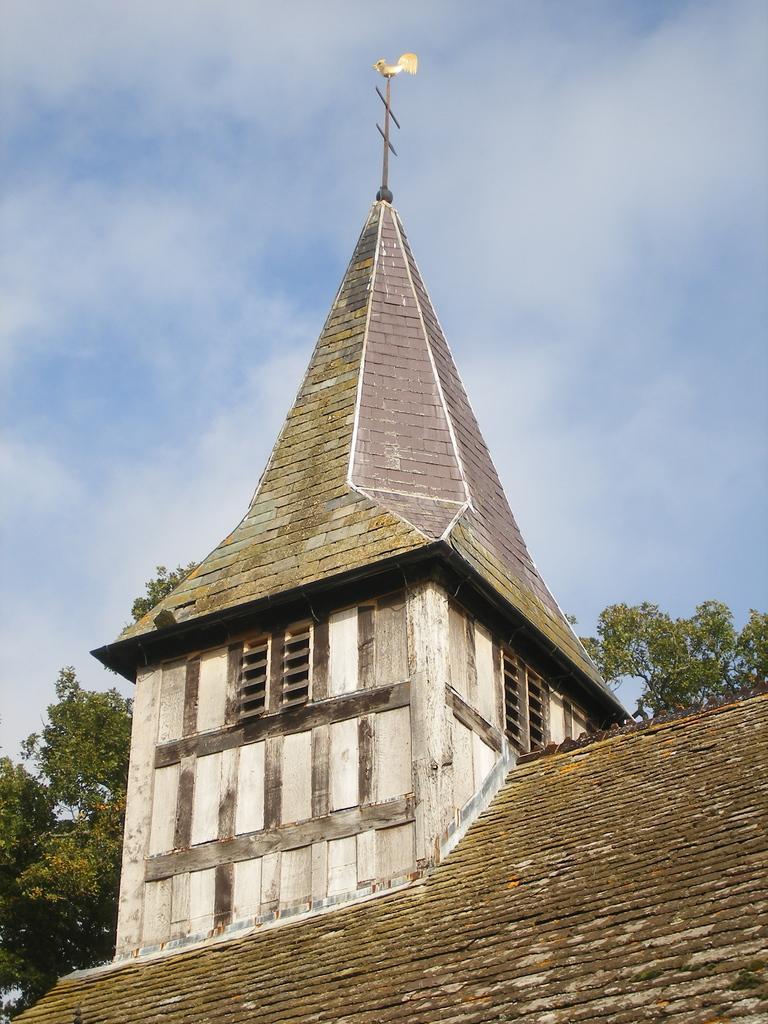In one or two sentences, can you explain what this image depicts? In this image I can see a building and number of trees. i can also see a clear blue sky in the background. 